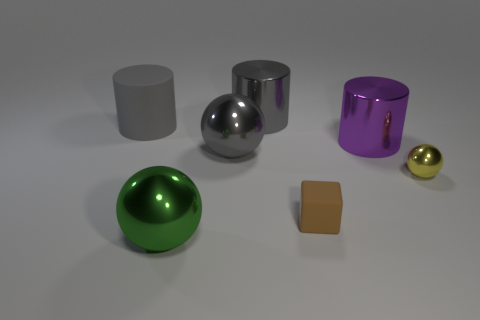There is a metallic object that is left of the gray shiny thing that is in front of the big cylinder that is to the right of the matte cube; what color is it? green 